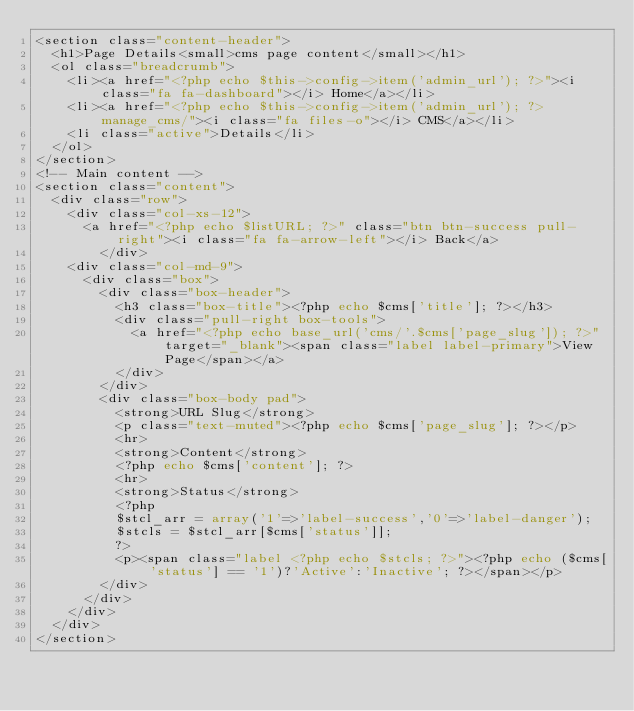Convert code to text. <code><loc_0><loc_0><loc_500><loc_500><_PHP_><section class="content-header">
	<h1>Page Details<small>cms page content</small></h1>
	<ol class="breadcrumb">
		<li><a href="<?php echo $this->config->item('admin_url'); ?>"><i class="fa fa-dashboard"></i> Home</a></li>
		<li><a href="<?php echo $this->config->item('admin_url'); ?>manage_cms/"><i class="fa files-o"></i> CMS</a></li>
		<li class="active">Details</li>
	</ol>
</section>
<!-- Main content -->
<section class="content">
	<div class="row">
		<div class="col-xs-12">
			<a href="<?php echo $listURL; ?>" class="btn btn-success pull-right"><i class="fa fa-arrow-left"></i> Back</a>
        </div>
		<div class="col-md-9">
			<div class="box">
				<div class="box-header">
					<h3 class="box-title"><?php echo $cms['title']; ?></h3>
					<div class="pull-right box-tools">
						<a href="<?php echo base_url('cms/'.$cms['page_slug']); ?>" target="_blank"><span class="label label-primary">View Page</span></a>
					</div>
				</div>
				<div class="box-body pad">
					<strong>URL Slug</strong>
					<p class="text-muted"><?php echo $cms['page_slug']; ?></p>
					<hr>
					<strong>Content</strong>
					<?php echo $cms['content']; ?>
					<hr>
					<strong>Status</strong>
					<?php
					$stcl_arr = array('1'=>'label-success','0'=>'label-danger');
					$stcls = $stcl_arr[$cms['status']];
					?>
					<p><span class="label <?php echo $stcls; ?>"><?php echo ($cms['status'] == '1')?'Active':'Inactive'; ?></span></p>
				</div>
			</div>
		</div>
	</div>
</section></code> 